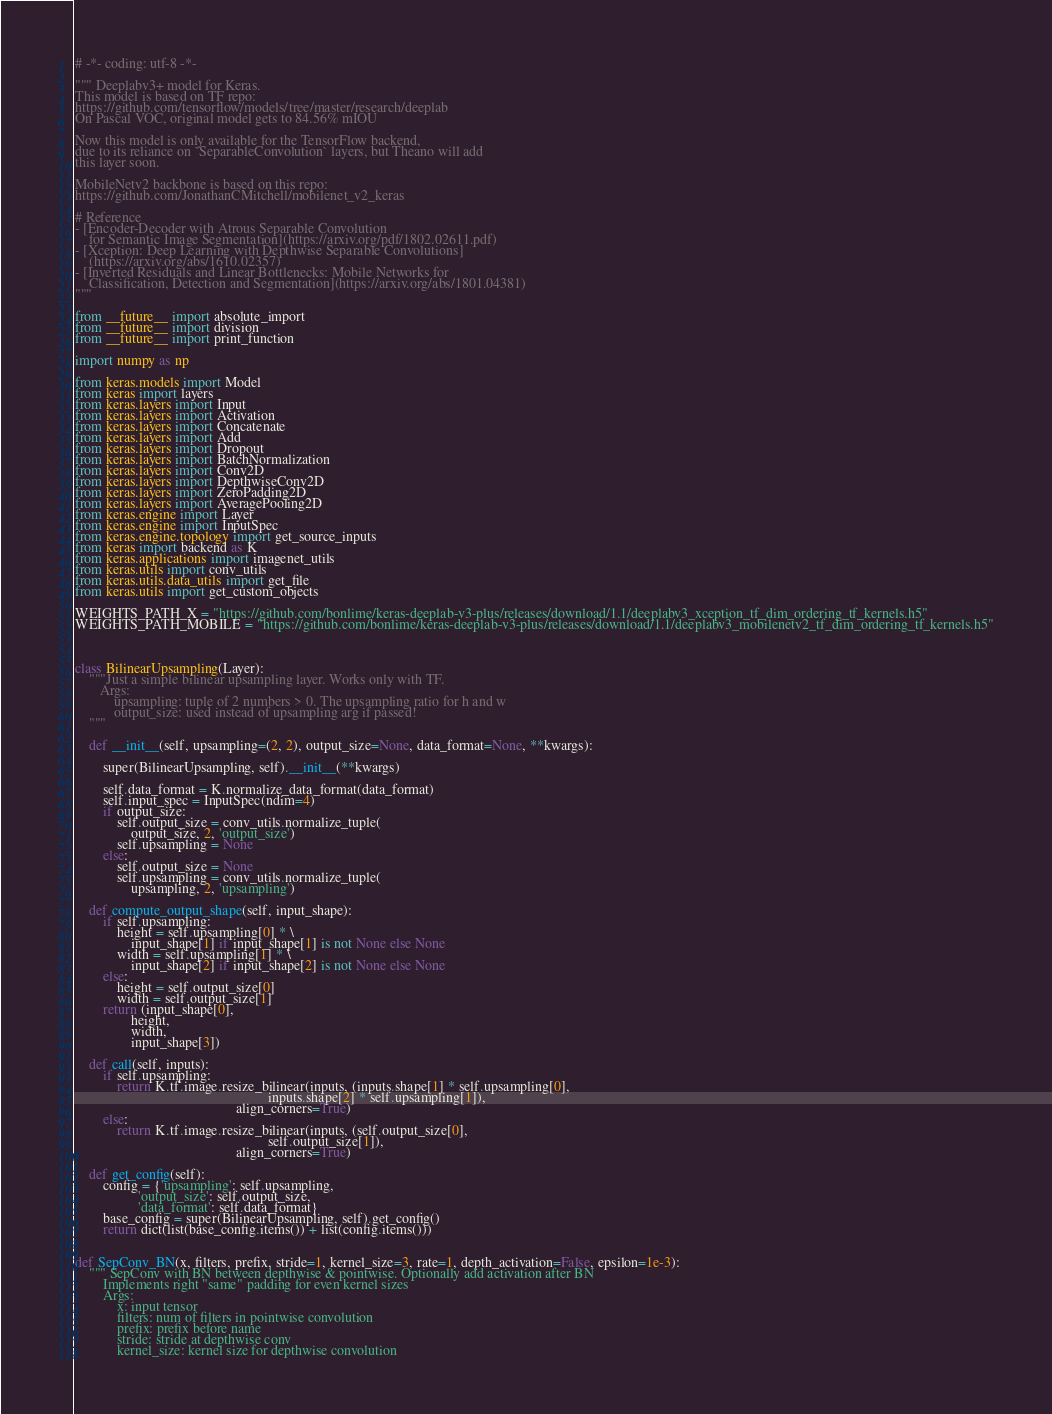<code> <loc_0><loc_0><loc_500><loc_500><_Python_># -*- coding: utf-8 -*-

""" Deeplabv3+ model for Keras.
This model is based on TF repo:
https://github.com/tensorflow/models/tree/master/research/deeplab
On Pascal VOC, original model gets to 84.56% mIOU

Now this model is only available for the TensorFlow backend,
due to its reliance on `SeparableConvolution` layers, but Theano will add
this layer soon.

MobileNetv2 backbone is based on this repo:
https://github.com/JonathanCMitchell/mobilenet_v2_keras

# Reference
- [Encoder-Decoder with Atrous Separable Convolution
    for Semantic Image Segmentation](https://arxiv.org/pdf/1802.02611.pdf)
- [Xception: Deep Learning with Depthwise Separable Convolutions]
    (https://arxiv.org/abs/1610.02357)
- [Inverted Residuals and Linear Bottlenecks: Mobile Networks for
    Classification, Detection and Segmentation](https://arxiv.org/abs/1801.04381)
"""

from __future__ import absolute_import
from __future__ import division
from __future__ import print_function

import numpy as np

from keras.models import Model
from keras import layers
from keras.layers import Input
from keras.layers import Activation
from keras.layers import Concatenate
from keras.layers import Add
from keras.layers import Dropout
from keras.layers import BatchNormalization
from keras.layers import Conv2D
from keras.layers import DepthwiseConv2D
from keras.layers import ZeroPadding2D
from keras.layers import AveragePooling2D
from keras.engine import Layer
from keras.engine import InputSpec
from keras.engine.topology import get_source_inputs
from keras import backend as K
from keras.applications import imagenet_utils
from keras.utils import conv_utils
from keras.utils.data_utils import get_file
from keras.utils import get_custom_objects

WEIGHTS_PATH_X = "https://github.com/bonlime/keras-deeplab-v3-plus/releases/download/1.1/deeplabv3_xception_tf_dim_ordering_tf_kernels.h5"
WEIGHTS_PATH_MOBILE = "https://github.com/bonlime/keras-deeplab-v3-plus/releases/download/1.1/deeplabv3_mobilenetv2_tf_dim_ordering_tf_kernels.h5"



class BilinearUpsampling(Layer):
    """Just a simple bilinear upsampling layer. Works only with TF.
       Args:
           upsampling: tuple of 2 numbers > 0. The upsampling ratio for h and w
           output_size: used instead of upsampling arg if passed!
    """

    def __init__(self, upsampling=(2, 2), output_size=None, data_format=None, **kwargs):

        super(BilinearUpsampling, self).__init__(**kwargs)

        self.data_format = K.normalize_data_format(data_format)
        self.input_spec = InputSpec(ndim=4)
        if output_size:
            self.output_size = conv_utils.normalize_tuple(
                output_size, 2, 'output_size')
            self.upsampling = None
        else:
            self.output_size = None
            self.upsampling = conv_utils.normalize_tuple(
                upsampling, 2, 'upsampling')

    def compute_output_shape(self, input_shape):
        if self.upsampling:
            height = self.upsampling[0] * \
                input_shape[1] if input_shape[1] is not None else None
            width = self.upsampling[1] * \
                input_shape[2] if input_shape[2] is not None else None
        else:
            height = self.output_size[0]
            width = self.output_size[1]
        return (input_shape[0],
                height,
                width,
                input_shape[3])

    def call(self, inputs):
        if self.upsampling:
            return K.tf.image.resize_bilinear(inputs, (inputs.shape[1] * self.upsampling[0],
                                                       inputs.shape[2] * self.upsampling[1]),
                                              align_corners=True)
        else:
            return K.tf.image.resize_bilinear(inputs, (self.output_size[0],
                                                       self.output_size[1]),
                                              align_corners=True)

    def get_config(self):
        config = {'upsampling': self.upsampling,
                  'output_size': self.output_size,
                  'data_format': self.data_format}
        base_config = super(BilinearUpsampling, self).get_config()
        return dict(list(base_config.items()) + list(config.items()))


def SepConv_BN(x, filters, prefix, stride=1, kernel_size=3, rate=1, depth_activation=False, epsilon=1e-3):
    """ SepConv with BN between depthwise & pointwise. Optionally add activation after BN
        Implements right "same" padding for even kernel sizes
        Args:
            x: input tensor
            filters: num of filters in pointwise convolution
            prefix: prefix before name
            stride: stride at depthwise conv
            kernel_size: kernel size for depthwise convolution</code> 